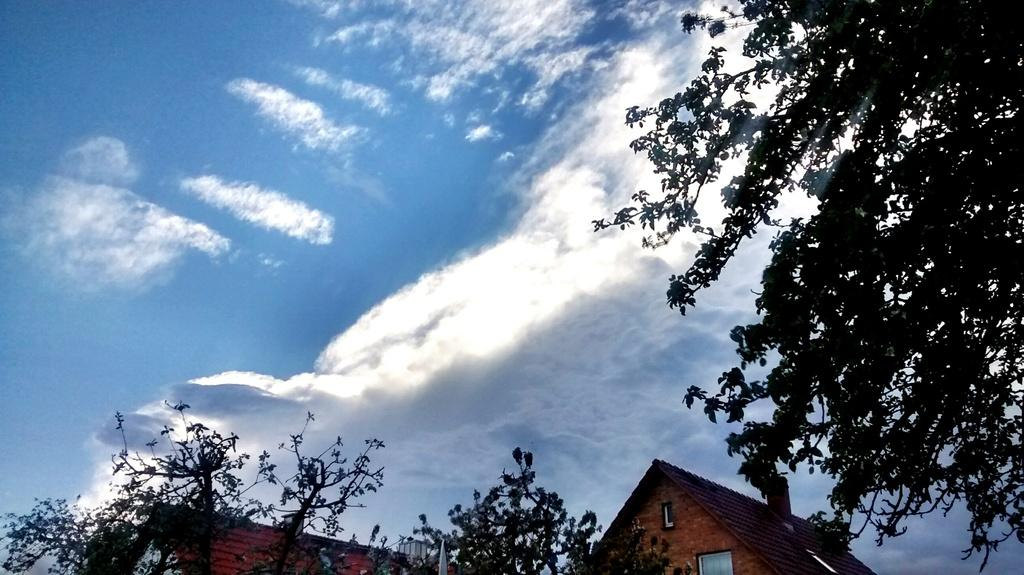What type of structure is visible in the image? The image contains an upper part of a house. What other object can be seen near the house? There is an upper part of a tree near the house. What is visible behind the house? The sky is visible behind the house. What can be observed in the sky? Clouds are present in the sky. What type of noise can be heard coming from the boot in the image? There is no boot present in the image, so it is not possible to determine what noise might be heard. 